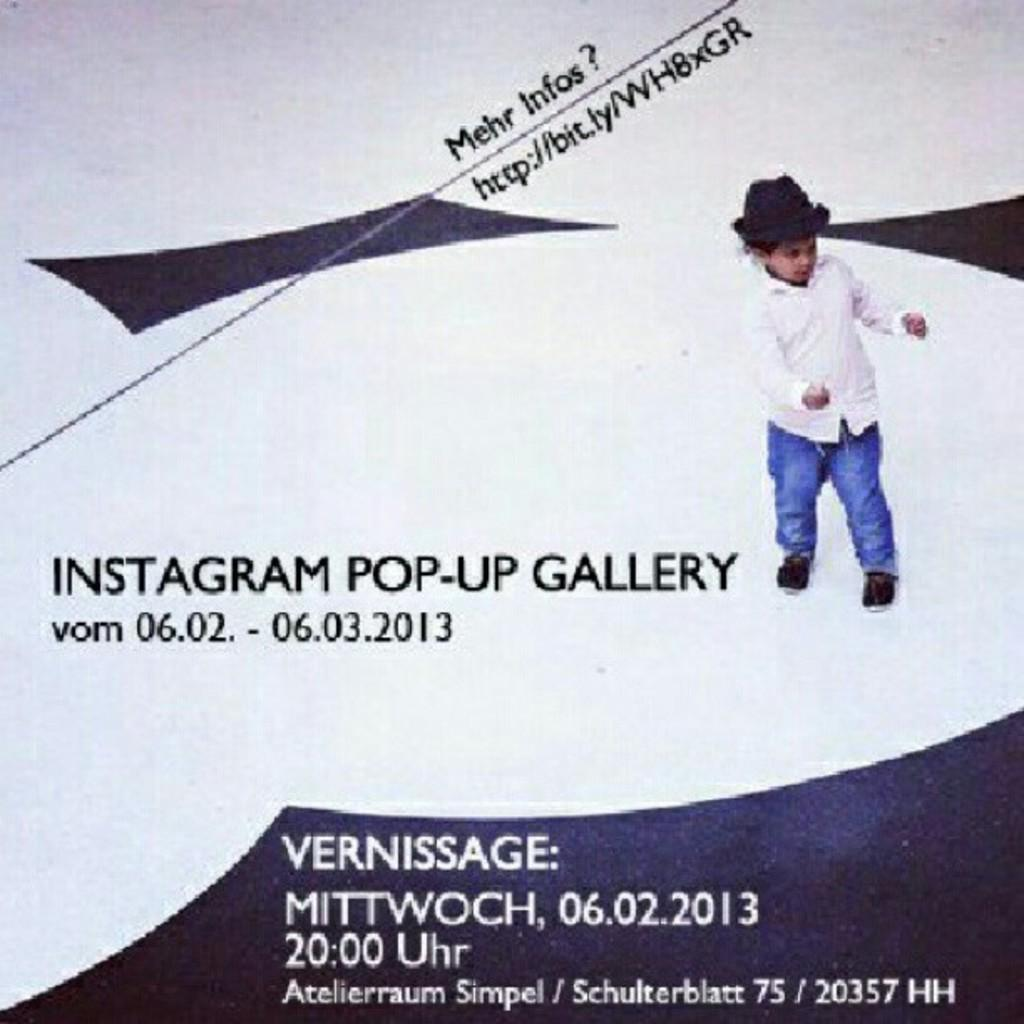What is present in the image? There is a poster in the image. What can be found on the poster? The poster contains text. What is depicted on the poster? There is a kid depicted in the poster. What type of science experiment is being conducted by the kid in the poster? There is no science experiment depicted in the image; the poster only contains text and a kid. 